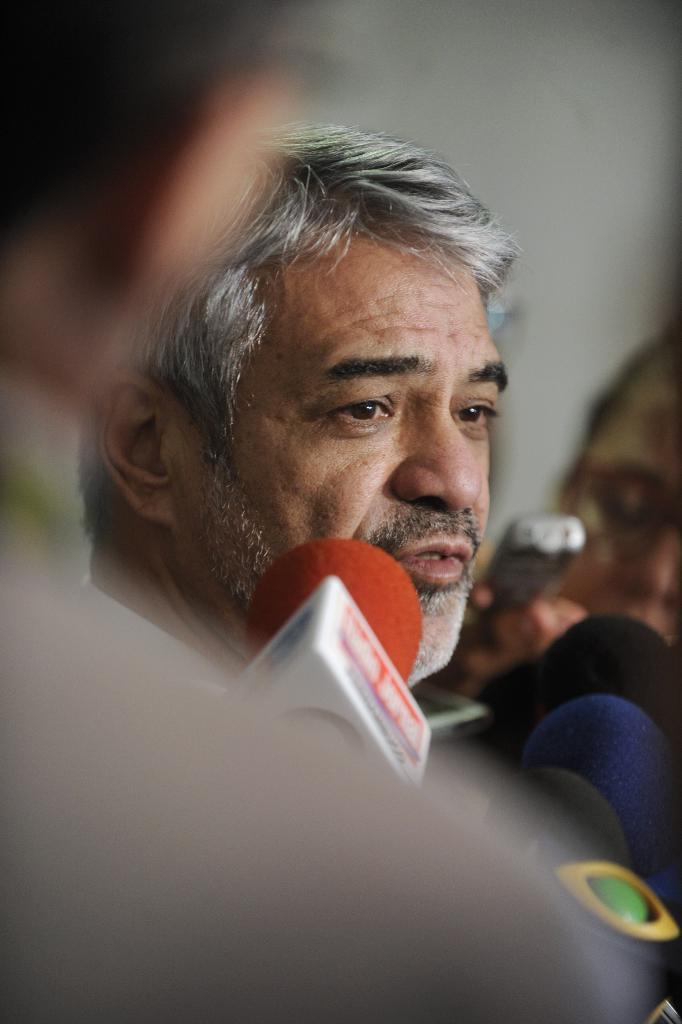In one or two sentences, can you explain what this image depicts? In the image few persons are holding microphones. Behind them a man is standing and watching. 